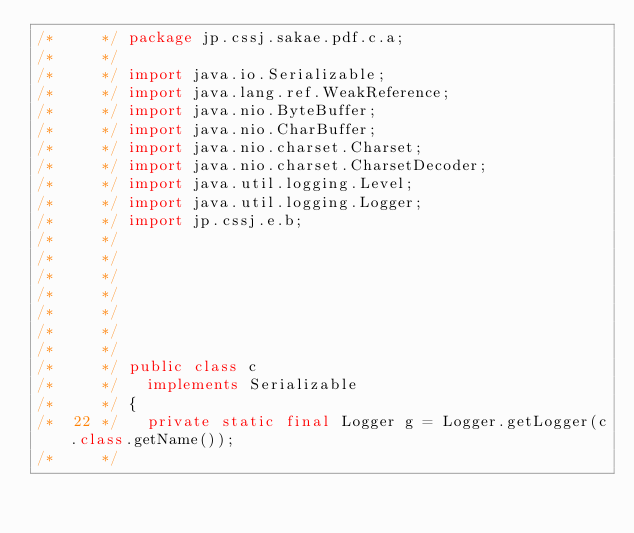<code> <loc_0><loc_0><loc_500><loc_500><_Java_>/*     */ package jp.cssj.sakae.pdf.c.a;
/*     */ 
/*     */ import java.io.Serializable;
/*     */ import java.lang.ref.WeakReference;
/*     */ import java.nio.ByteBuffer;
/*     */ import java.nio.CharBuffer;
/*     */ import java.nio.charset.Charset;
/*     */ import java.nio.charset.CharsetDecoder;
/*     */ import java.util.logging.Level;
/*     */ import java.util.logging.Logger;
/*     */ import jp.cssj.e.b;
/*     */ 
/*     */ 
/*     */ 
/*     */ 
/*     */ 
/*     */ 
/*     */ 
/*     */ public class c
/*     */   implements Serializable
/*     */ {
/*  22 */   private static final Logger g = Logger.getLogger(c.class.getName());
/*     */   </code> 